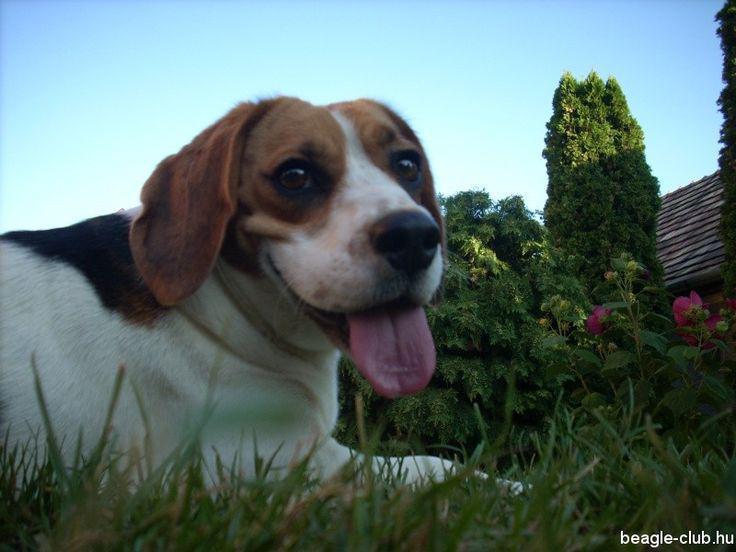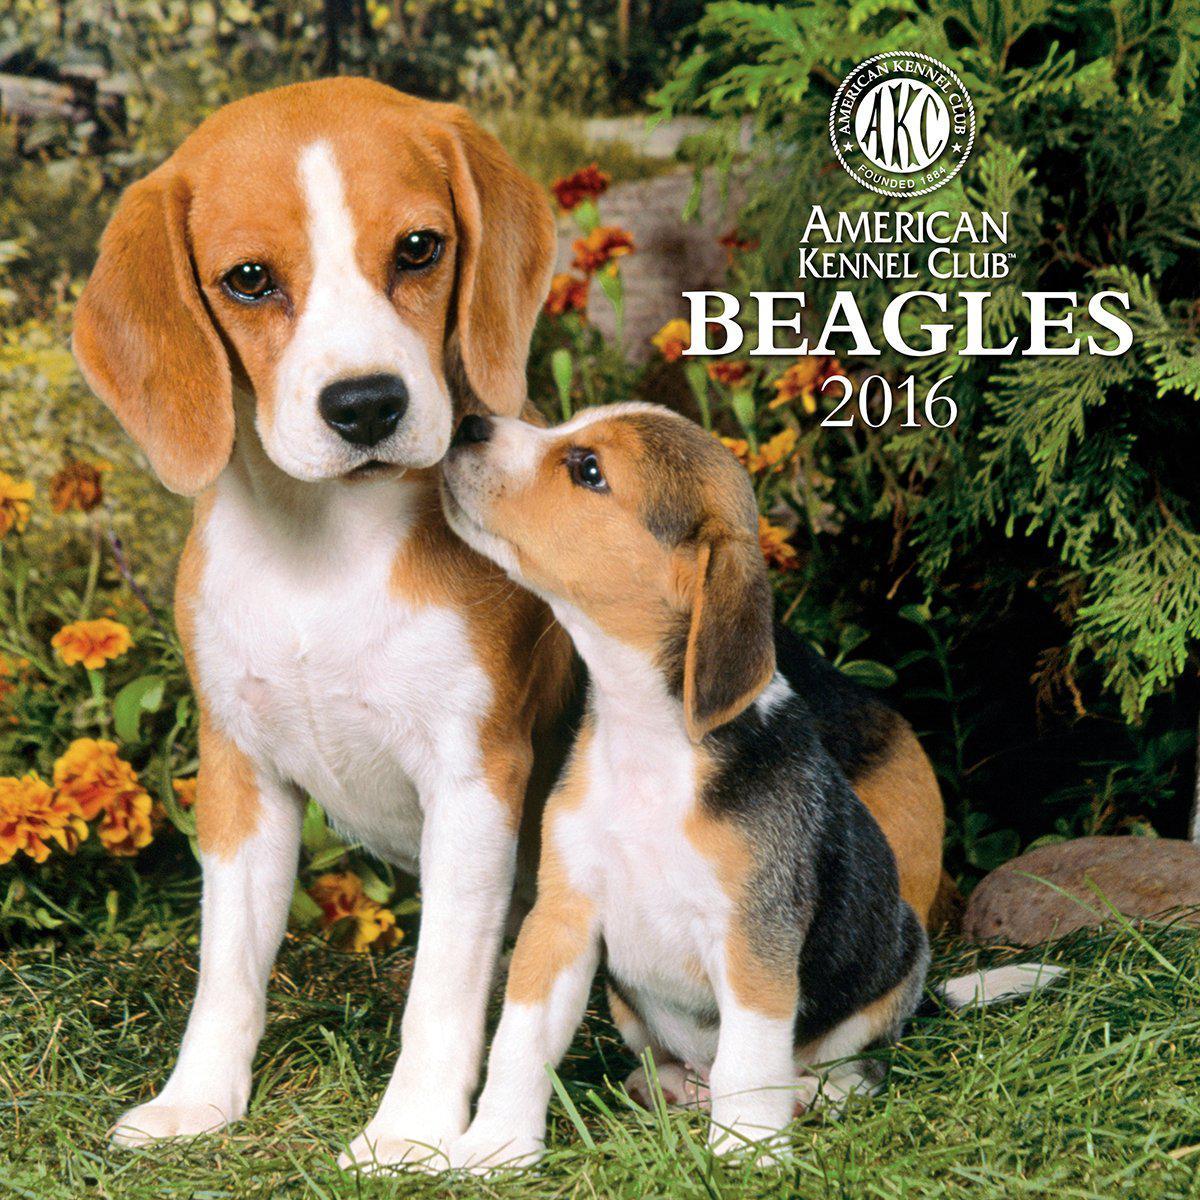The first image is the image on the left, the second image is the image on the right. Evaluate the accuracy of this statement regarding the images: "There are two dogs in the right image.". Is it true? Answer yes or no. Yes. The first image is the image on the left, the second image is the image on the right. Considering the images on both sides, is "Flowers of some type are behind a dog in at least one image, and at least one image includes a beagle puppy." valid? Answer yes or no. Yes. 